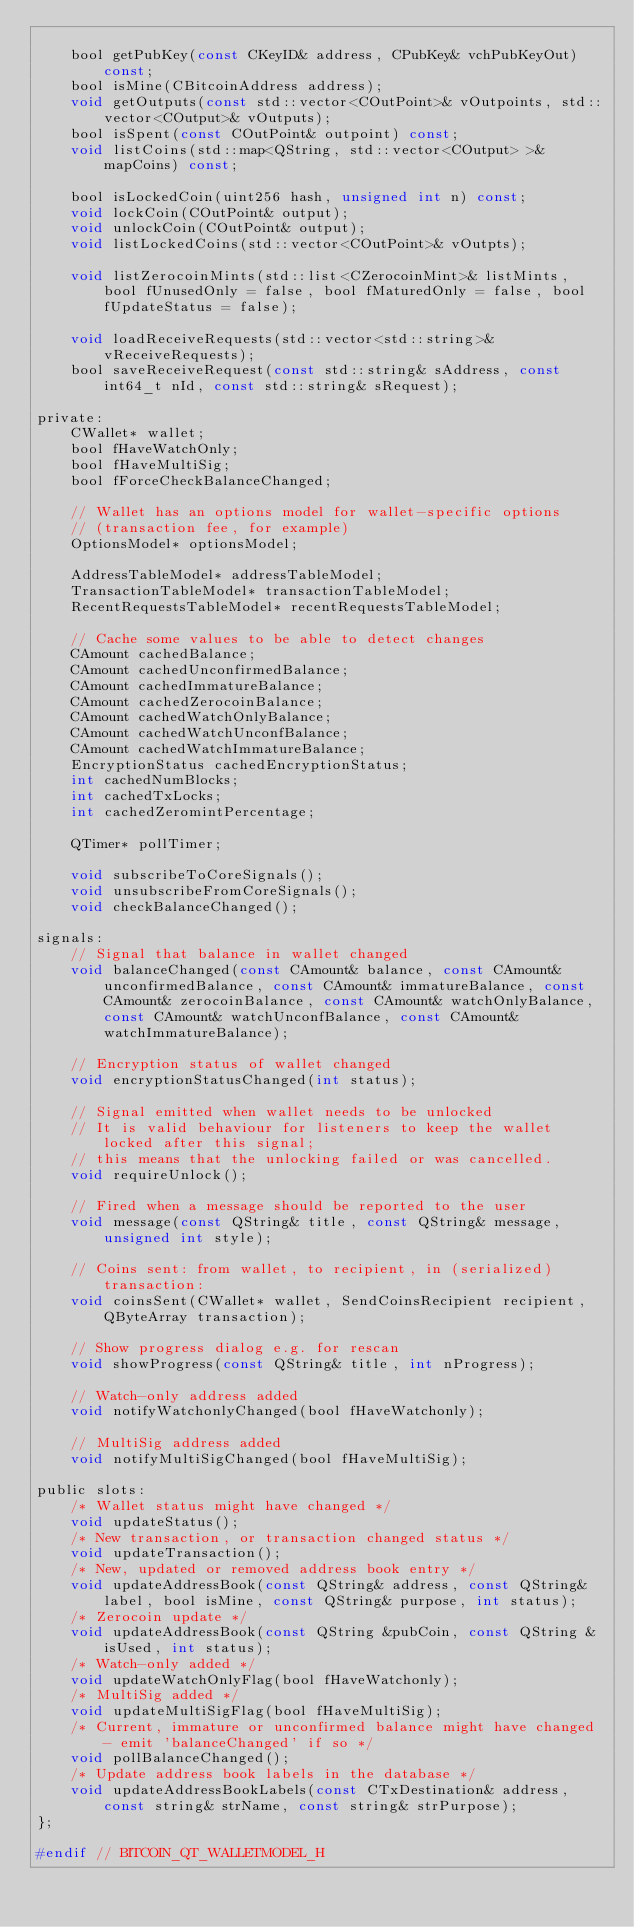<code> <loc_0><loc_0><loc_500><loc_500><_C_>
    bool getPubKey(const CKeyID& address, CPubKey& vchPubKeyOut) const;
    bool isMine(CBitcoinAddress address);
    void getOutputs(const std::vector<COutPoint>& vOutpoints, std::vector<COutput>& vOutputs);
    bool isSpent(const COutPoint& outpoint) const;
    void listCoins(std::map<QString, std::vector<COutput> >& mapCoins) const;

    bool isLockedCoin(uint256 hash, unsigned int n) const;
    void lockCoin(COutPoint& output);
    void unlockCoin(COutPoint& output);
    void listLockedCoins(std::vector<COutPoint>& vOutpts);

    void listZerocoinMints(std::list<CZerocoinMint>& listMints, bool fUnusedOnly = false, bool fMaturedOnly = false, bool fUpdateStatus = false);

    void loadReceiveRequests(std::vector<std::string>& vReceiveRequests);
    bool saveReceiveRequest(const std::string& sAddress, const int64_t nId, const std::string& sRequest);

private:
    CWallet* wallet;
    bool fHaveWatchOnly;
    bool fHaveMultiSig;
    bool fForceCheckBalanceChanged;

    // Wallet has an options model for wallet-specific options
    // (transaction fee, for example)
    OptionsModel* optionsModel;

    AddressTableModel* addressTableModel;
    TransactionTableModel* transactionTableModel;
    RecentRequestsTableModel* recentRequestsTableModel;

    // Cache some values to be able to detect changes
    CAmount cachedBalance;
    CAmount cachedUnconfirmedBalance;
    CAmount cachedImmatureBalance;
    CAmount cachedZerocoinBalance;
    CAmount cachedWatchOnlyBalance;
    CAmount cachedWatchUnconfBalance;
    CAmount cachedWatchImmatureBalance;
    EncryptionStatus cachedEncryptionStatus;
    int cachedNumBlocks;
    int cachedTxLocks;
    int cachedZeromintPercentage;

    QTimer* pollTimer;

    void subscribeToCoreSignals();
    void unsubscribeFromCoreSignals();
    void checkBalanceChanged();

signals:
    // Signal that balance in wallet changed
    void balanceChanged(const CAmount& balance, const CAmount& unconfirmedBalance, const CAmount& immatureBalance, const CAmount& zerocoinBalance, const CAmount& watchOnlyBalance, const CAmount& watchUnconfBalance, const CAmount& watchImmatureBalance);

    // Encryption status of wallet changed
    void encryptionStatusChanged(int status);

    // Signal emitted when wallet needs to be unlocked
    // It is valid behaviour for listeners to keep the wallet locked after this signal;
    // this means that the unlocking failed or was cancelled.
    void requireUnlock();

    // Fired when a message should be reported to the user
    void message(const QString& title, const QString& message, unsigned int style);

    // Coins sent: from wallet, to recipient, in (serialized) transaction:
    void coinsSent(CWallet* wallet, SendCoinsRecipient recipient, QByteArray transaction);

    // Show progress dialog e.g. for rescan
    void showProgress(const QString& title, int nProgress);

    // Watch-only address added
    void notifyWatchonlyChanged(bool fHaveWatchonly);

    // MultiSig address added
    void notifyMultiSigChanged(bool fHaveMultiSig);

public slots:
    /* Wallet status might have changed */
    void updateStatus();
    /* New transaction, or transaction changed status */
    void updateTransaction();
    /* New, updated or removed address book entry */
    void updateAddressBook(const QString& address, const QString& label, bool isMine, const QString& purpose, int status);
    /* Zerocoin update */
    void updateAddressBook(const QString &pubCoin, const QString &isUsed, int status);
    /* Watch-only added */
    void updateWatchOnlyFlag(bool fHaveWatchonly);
    /* MultiSig added */
    void updateMultiSigFlag(bool fHaveMultiSig);
    /* Current, immature or unconfirmed balance might have changed - emit 'balanceChanged' if so */
    void pollBalanceChanged();
    /* Update address book labels in the database */
    void updateAddressBookLabels(const CTxDestination& address, const string& strName, const string& strPurpose);
};

#endif // BITCOIN_QT_WALLETMODEL_H
</code> 